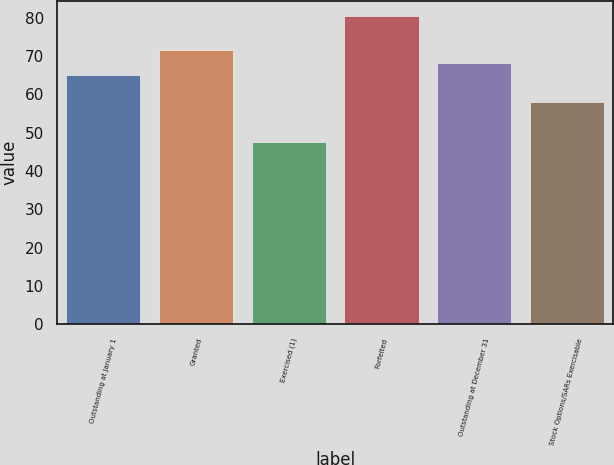Convert chart. <chart><loc_0><loc_0><loc_500><loc_500><bar_chart><fcel>Outstanding at January 1<fcel>Granted<fcel>Exercised (1)<fcel>Forfeited<fcel>Outstanding at December 31<fcel>Stock Options/SARs Exercisable<nl><fcel>64.96<fcel>71.5<fcel>47.64<fcel>80.31<fcel>68.23<fcel>57.96<nl></chart> 